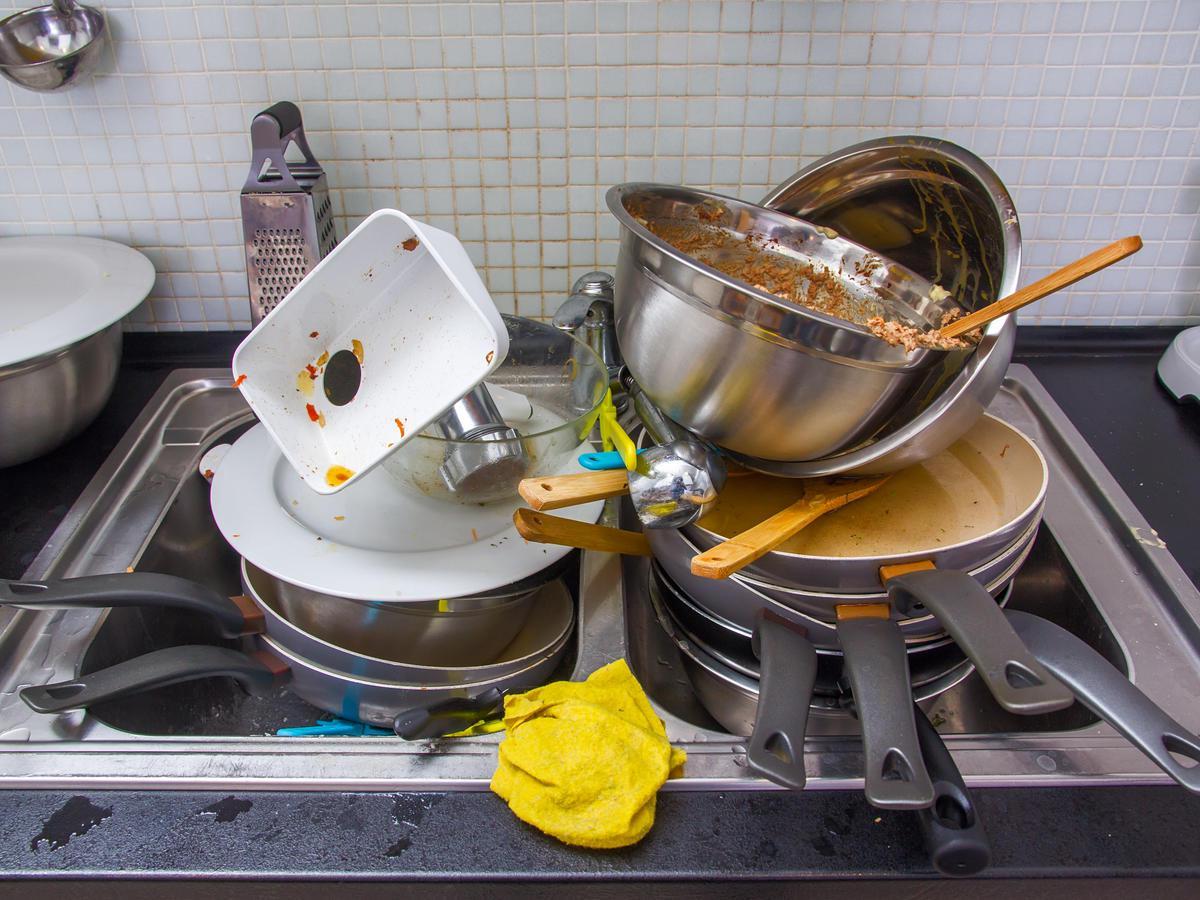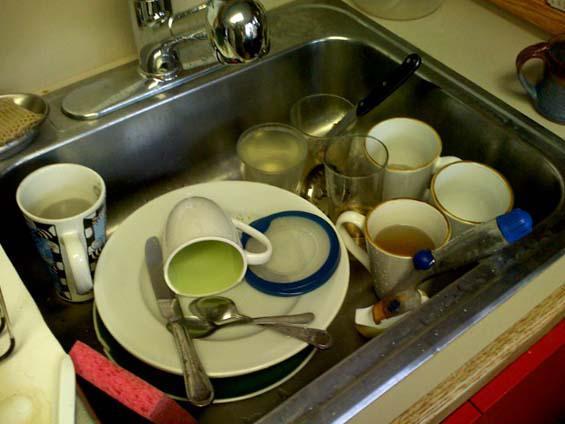The first image is the image on the left, the second image is the image on the right. Given the left and right images, does the statement "At least one window is visible behind a pile of dirty dishes." hold true? Answer yes or no. No. The first image is the image on the left, the second image is the image on the right. Evaluate the accuracy of this statement regarding the images: "A big upright squarish cutting board is behind a heaping pile of dirty dishes in a sink.". Is it true? Answer yes or no. No. 